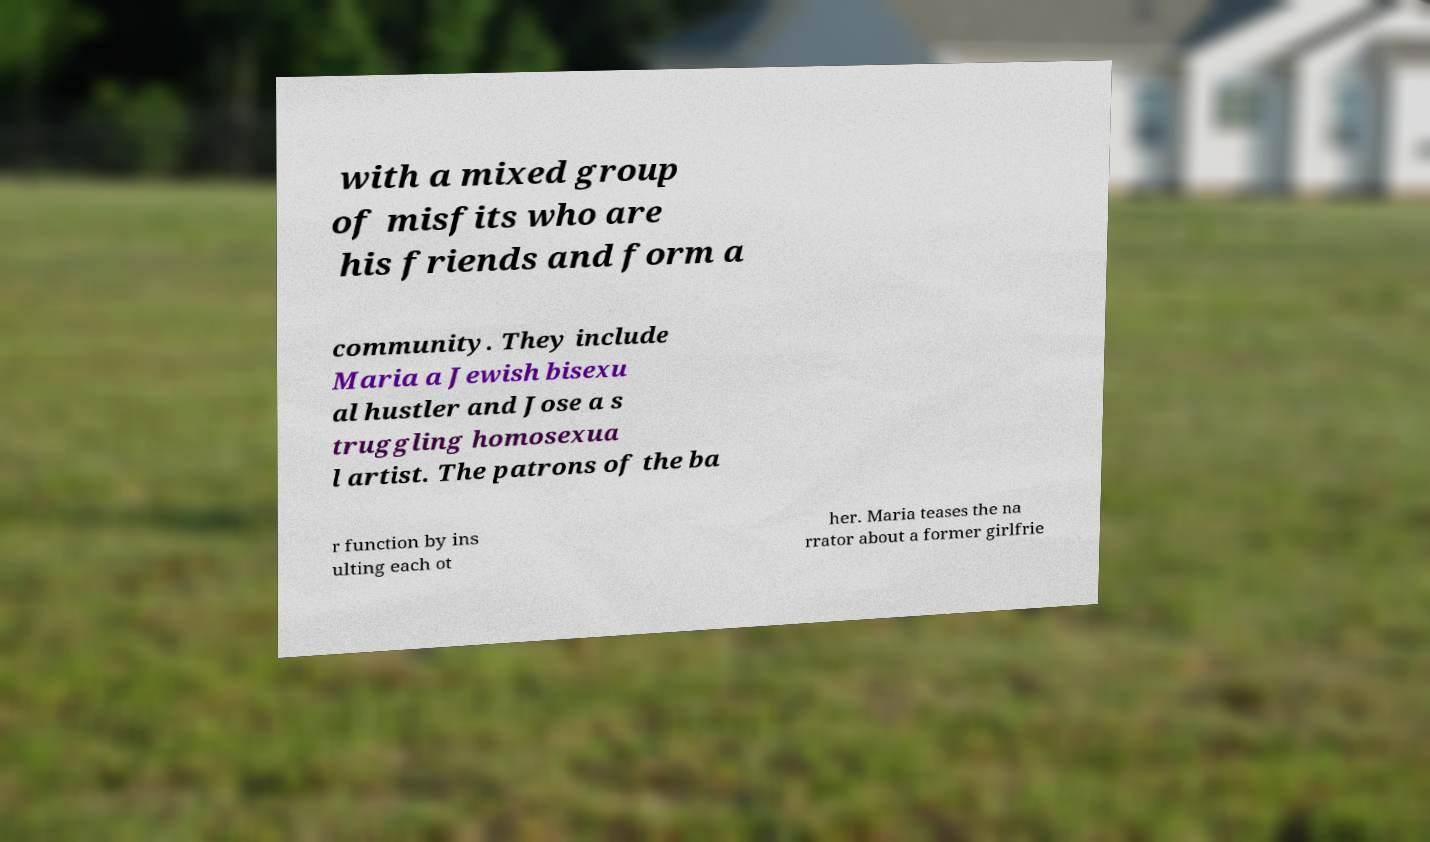Please read and relay the text visible in this image. What does it say? with a mixed group of misfits who are his friends and form a community. They include Maria a Jewish bisexu al hustler and Jose a s truggling homosexua l artist. The patrons of the ba r function by ins ulting each ot her. Maria teases the na rrator about a former girlfrie 